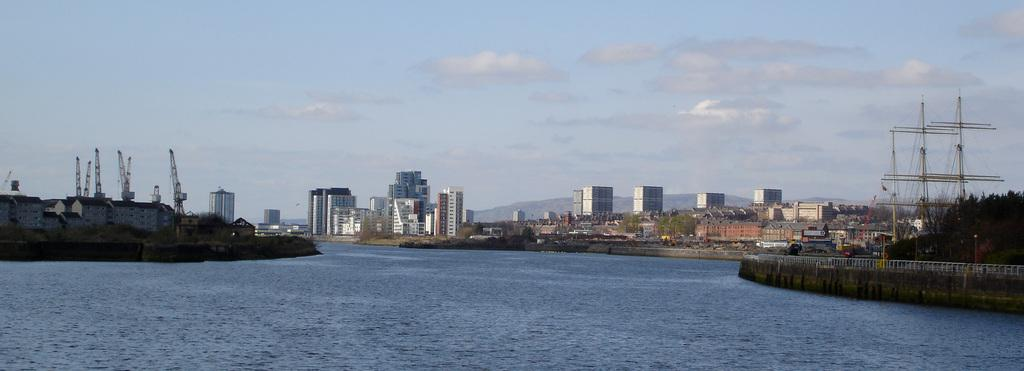What type of structures can be seen in the image? There are buildings in the image. What natural elements are present in the image? There are trees in the image. What man-made objects can be seen in the image? There are poles and fencing in the image. What is the condition of the water in the image? There is water visible in the image. What type of machinery is present in the image? There are cranes in the image. What is the color of the sky in the image? The sky is blue and white in color. What type of disease is affecting the trees in the image? There is no indication of any disease affecting the trees in the image; they appear to be healthy. Can you tell me how many cars are visible in the image? There are no cars present in the image. Is the water in the image a sea or an ocean? The image does not provide enough information to determine if the water is a sea or an ocean; it only shows that there is water visible. 